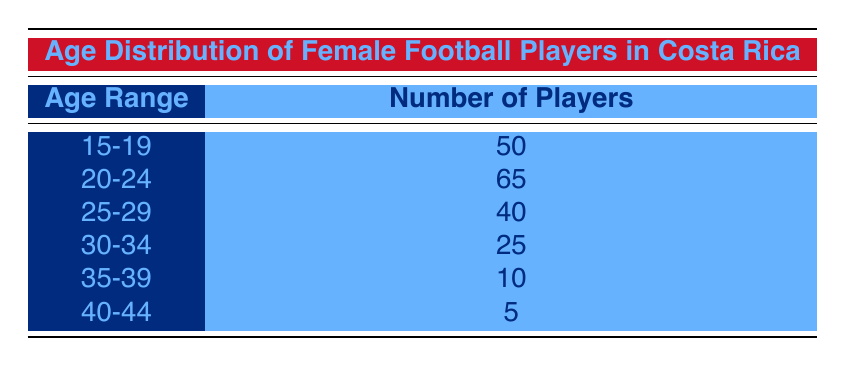What is the age range with the highest number of players? The age range with the highest number of players can be found by looking at the 'Number of Players' column. Scanning through the values, 65 is the highest number, which corresponds to the age range of 20-24.
Answer: 20-24 How many players are in the age group 30-34? The table directly lists the number of players in the age group 30-34 as 25.
Answer: 25 What is the total number of players across all age groups? To find the total number of players, sum all the values in the 'Number of Players' column: 50 + 65 + 40 + 25 + 10 + 5 = 195.
Answer: 195 Is there an equal number of players in any two age groups? Examining the 'Number of Players' for all age groups, no two age groups have the same number of players; all values are unique.
Answer: No Which age group has the least number of players? Looking at the 'Number of Players' column, the group with the least number is 40-44, which has only 5 players.
Answer: 40-44 What is the average number of players in the age groups presented? To determine the average, first calculate the total number of players (195), then divide by the number of age groups (6): 195/6 = 32.5.
Answer: 32.5 How many players are in age groups that are 30 years or older? The applicable age groups are 30-34 (25), 35-39 (10), and 40-44 (5). Adding these gives: 25 + 10 + 5 = 40 players.
Answer: 40 Is the number of players aged 25-29 greater than those aged 35-39? Comparing the two values, the age group 25-29 has 40 players, while 35-39 has 10 players. Since 40 is greater than 10, the statement is true.
Answer: Yes What percentage of players are aged 15-19 compared to the total number of players? The group aged 15-19 has 50 players. To find the percentage, use the formula (50/195) * 100 = 25.64%.
Answer: 25.64% 